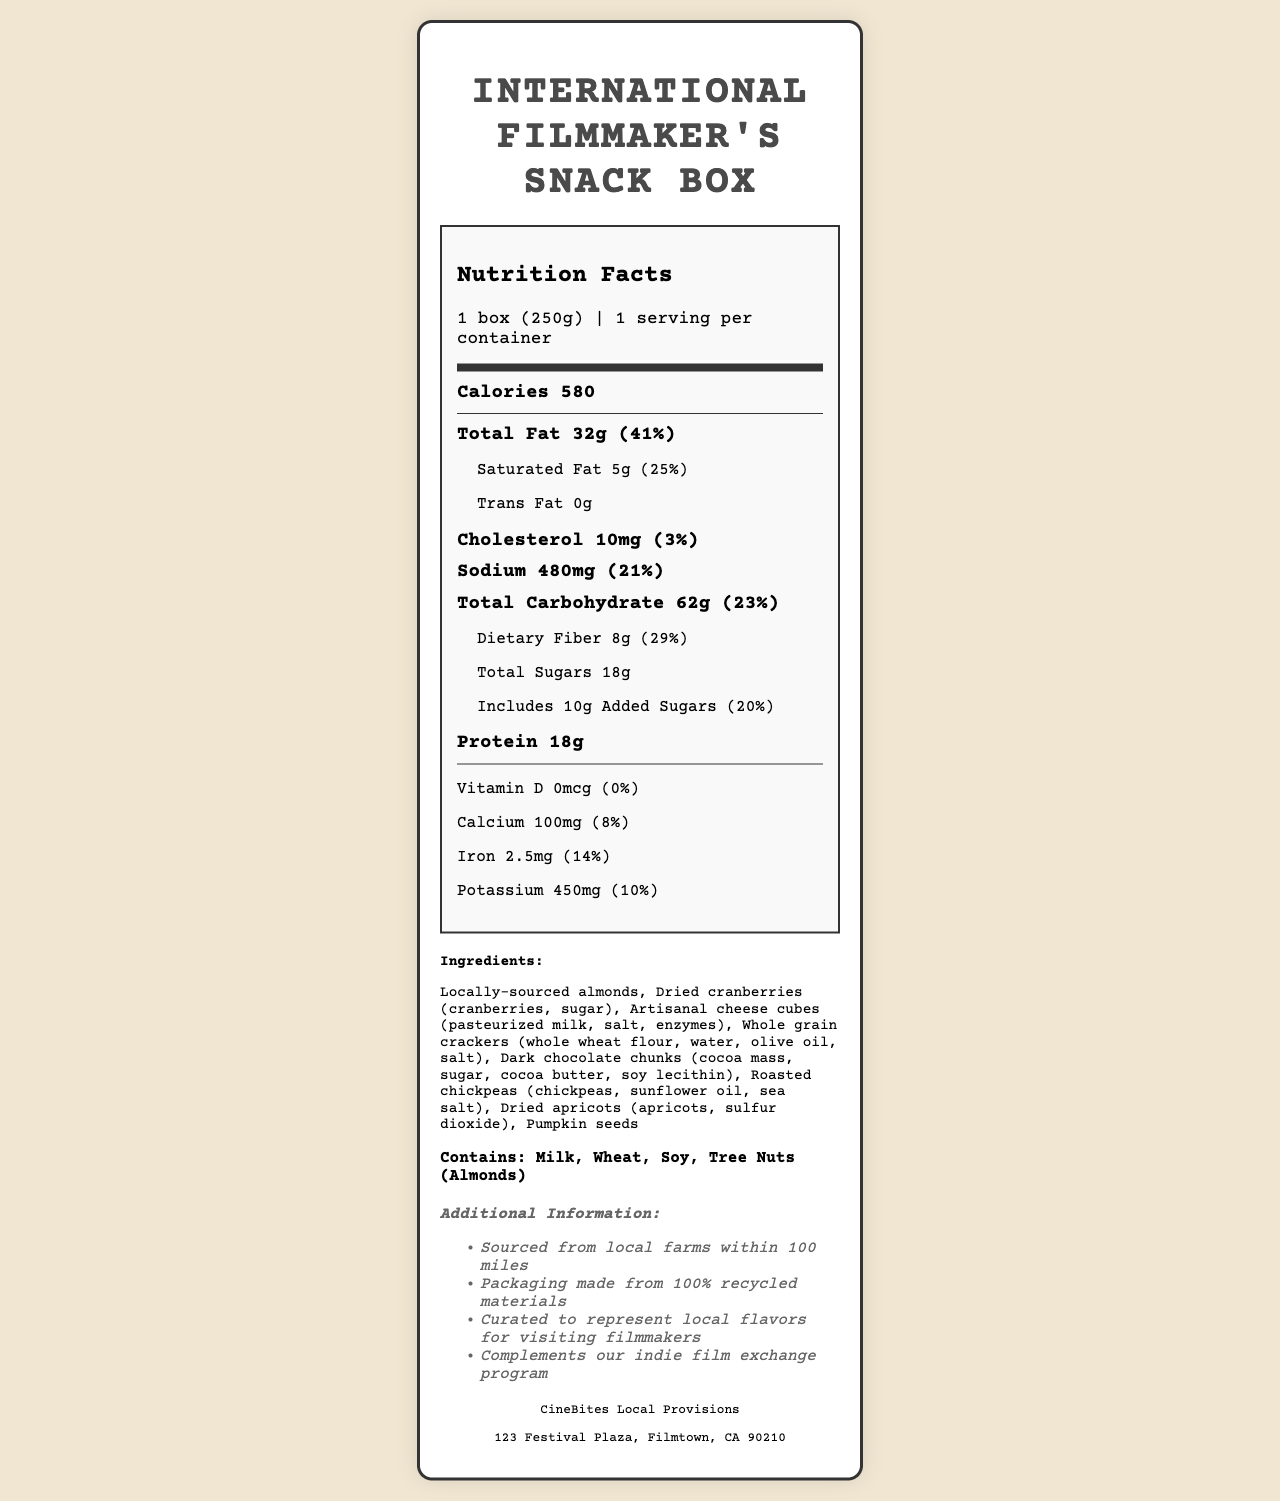who is the manufacturer of the snack box? The manufacturer is listed at the bottom of the document.
Answer: CineBites Local Provisions what is the serving size of the International Filmmaker's Snack Box? The serving size is specified as "1 box (250g)" in the document.
Answer: 1 box (250g) how many grams of protein are in one serving? The document states that there are 18 grams of protein per serving.
Answer: 18g how many servings are in one container? It is stated that there is 1 serving per container in the document.
Answer: 1 what is the amount of saturated fat in the snack box? The saturated fat amount is specified as 5 grams.
Answer: 5g how much cholesterol is in one serving? A. 5mg B. 10mg C. 15mg D. 20mg The document indicates that there are 10mg of cholesterol in one serving.
Answer: B. 10mg what percentage of the daily value of calcium is provided by this snack box? A. 5% B. 8% C. 10% D. 12% The document specifies that the snack box provides 8% of the daily value for calcium.
Answer: B. 8% does this product contain any trans fat? The document lists the trans fat content as 0g.
Answer: No does the snack box contain any soy? The allergen information at the bottom of the document includes soy.
Answer: Yes summarize the main idea of the document. The summary covers all the main areas of the document: nutritional information, ingredients, allergen details, and additional context about the product's origins and purpose.
Answer: The document provides a detailed nutritional profile of the International Filmmaker's Snack Box, including its serving size, calorie content, breakdowns of fats, carbohydrates, and protein, and a list of ingredients along with allergen information. The snack box is designed to offer local flavors to international filmmakers and is produced by CineBites Local Provisions with locally-sourced ingredients. is the fiber content more than 20% of the daily value? The document states that the dietary fiber content is 29% of the daily value, which is more than 20%.
Answer: Yes how many grams of added sugars are in the snack box? The document states that there are 10 grams of added sugars in the snack box.
Answer: 10g does the snack box have any vitamin D? The document indicates that the content of vitamin D is 0mcg, which is 0% of the daily value.
Answer: No are the ingredients sourced from international suppliers? The document only mentions that ingredients are "sourced from local farms within 100 miles," without specifying anything about international suppliers.
Answer: Not enough information what makes this snack box unique compared to other snack products? The document includes additional information that highlights the snack box's uniqueness in terms of local sourcing and representation of local flavors for international filmmakers.
Answer: It is specially curated to represent local flavors for visiting filmmakers and sourced from local farms within 100 miles. 